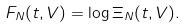Convert formula to latex. <formula><loc_0><loc_0><loc_500><loc_500>F _ { N } ( t , V ) = \log \Xi _ { N } ( t , V ) .</formula> 